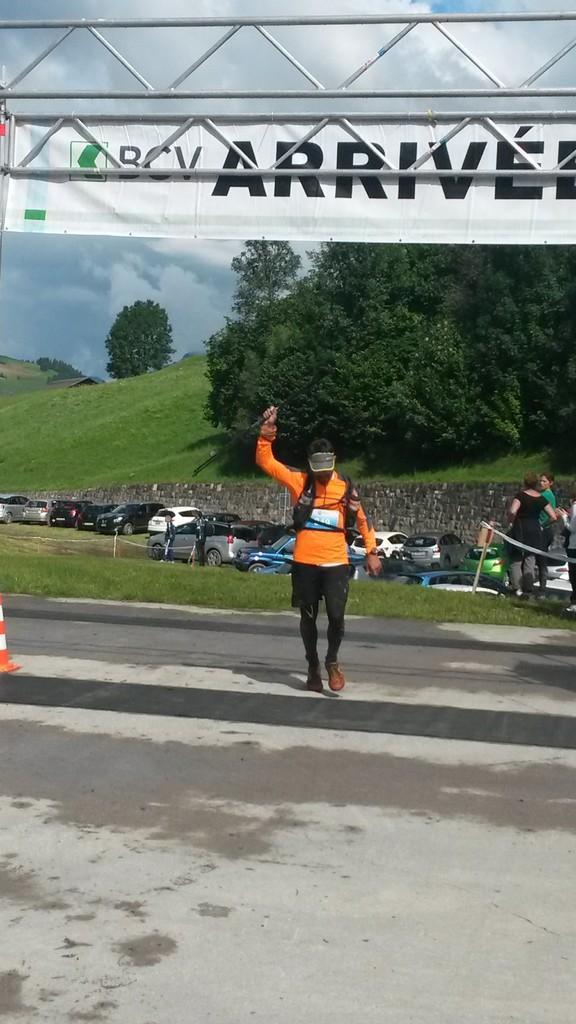Describe this image in one or two sentences. In the center of the image we can see a man walking. At the top there is a banner and we can see rods. In the background there are trees, cars and sky. On the right there are people. On the left there is a traffic cone. 